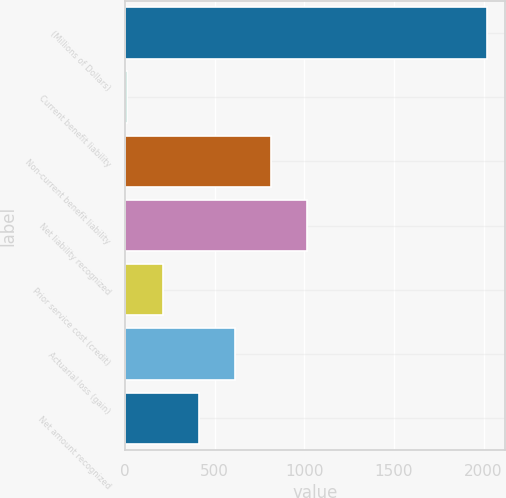Convert chart to OTSL. <chart><loc_0><loc_0><loc_500><loc_500><bar_chart><fcel>(Millions of Dollars)<fcel>Current benefit liability<fcel>Non-current benefit liability<fcel>Net liability recognized<fcel>Prior service cost (credit)<fcel>Actuarial loss (gain)<fcel>Net amount recognized<nl><fcel>2018<fcel>9.1<fcel>812.66<fcel>1013.55<fcel>209.99<fcel>611.77<fcel>410.88<nl></chart> 